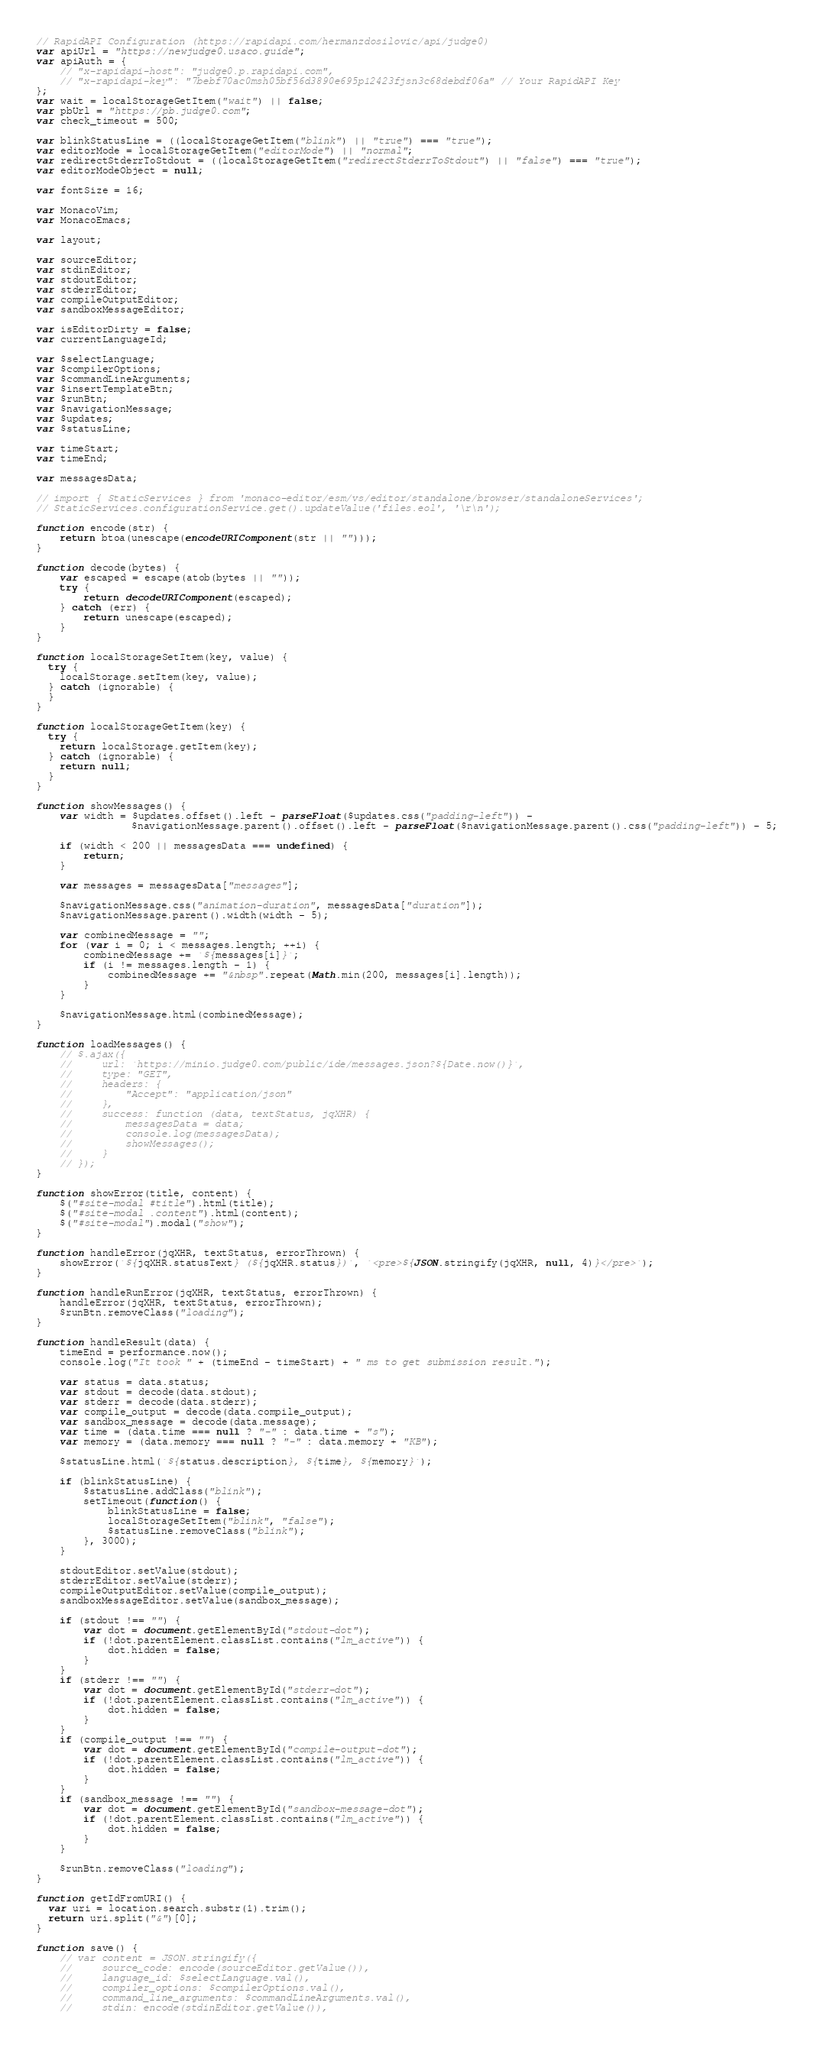Convert code to text. <code><loc_0><loc_0><loc_500><loc_500><_JavaScript_>// RapidAPI Configuration (https://rapidapi.com/hermanzdosilovic/api/judge0)
var apiUrl = "https://newjudge0.usaco.guide";
var apiAuth = {
    // "x-rapidapi-host": "judge0.p.rapidapi.com",
    // "x-rapidapi-key": "7bebf70ac0msh05bf56d3890e695p12423fjsn3c68debdf06a" // Your RapidAPI Key
};
var wait = localStorageGetItem("wait") || false;
var pbUrl = "https://pb.judge0.com";
var check_timeout = 500;

var blinkStatusLine = ((localStorageGetItem("blink") || "true") === "true");
var editorMode = localStorageGetItem("editorMode") || "normal";
var redirectStderrToStdout = ((localStorageGetItem("redirectStderrToStdout") || "false") === "true");
var editorModeObject = null;

var fontSize = 16;

var MonacoVim;
var MonacoEmacs;

var layout;

var sourceEditor;
var stdinEditor;
var stdoutEditor;
var stderrEditor;
var compileOutputEditor;
var sandboxMessageEditor;

var isEditorDirty = false;
var currentLanguageId;

var $selectLanguage;
var $compilerOptions;
var $commandLineArguments;
var $insertTemplateBtn;
var $runBtn;
var $navigationMessage;
var $updates;
var $statusLine;

var timeStart;
var timeEnd;

var messagesData;

// import { StaticServices } from 'monaco-editor/esm/vs/editor/standalone/browser/standaloneServices';
// StaticServices.configurationService.get().updateValue('files.eol', '\r\n');

function encode(str) {
    return btoa(unescape(encodeURIComponent(str || "")));
}

function decode(bytes) {
    var escaped = escape(atob(bytes || ""));
    try {
        return decodeURIComponent(escaped);
    } catch (err) {
        return unescape(escaped);
    }
}

function localStorageSetItem(key, value) {
  try {
    localStorage.setItem(key, value);
  } catch (ignorable) {
  }
}

function localStorageGetItem(key) {
  try {
    return localStorage.getItem(key);
  } catch (ignorable) {
    return null;
  }
}

function showMessages() {
    var width = $updates.offset().left - parseFloat($updates.css("padding-left")) -
                $navigationMessage.parent().offset().left - parseFloat($navigationMessage.parent().css("padding-left")) - 5;

    if (width < 200 || messagesData === undefined) {
        return;
    }

    var messages = messagesData["messages"];

    $navigationMessage.css("animation-duration", messagesData["duration"]);
    $navigationMessage.parent().width(width - 5);

    var combinedMessage = "";
    for (var i = 0; i < messages.length; ++i) {
        combinedMessage += `${messages[i]}`;
        if (i != messages.length - 1) {
            combinedMessage += "&nbsp".repeat(Math.min(200, messages[i].length));
        }
    }

    $navigationMessage.html(combinedMessage);
}

function loadMessages() {
    // $.ajax({
    //     url: `https://minio.judge0.com/public/ide/messages.json?${Date.now()}`,
    //     type: "GET",
    //     headers: {
    //         "Accept": "application/json"
    //     },
    //     success: function (data, textStatus, jqXHR) {
    //         messagesData = data;
    //         console.log(messagesData);
    //         showMessages();
    //     }
    // });
}

function showError(title, content) {
    $("#site-modal #title").html(title);
    $("#site-modal .content").html(content);
    $("#site-modal").modal("show");
}

function handleError(jqXHR, textStatus, errorThrown) {
    showError(`${jqXHR.statusText} (${jqXHR.status})`, `<pre>${JSON.stringify(jqXHR, null, 4)}</pre>`);
}

function handleRunError(jqXHR, textStatus, errorThrown) {
    handleError(jqXHR, textStatus, errorThrown);
    $runBtn.removeClass("loading");
}

function handleResult(data) {
    timeEnd = performance.now();
    console.log("It took " + (timeEnd - timeStart) + " ms to get submission result.");

    var status = data.status;
    var stdout = decode(data.stdout);
    var stderr = decode(data.stderr);
    var compile_output = decode(data.compile_output);
    var sandbox_message = decode(data.message);
    var time = (data.time === null ? "-" : data.time + "s");
    var memory = (data.memory === null ? "-" : data.memory + "KB");

    $statusLine.html(`${status.description}, ${time}, ${memory}`);

    if (blinkStatusLine) {
        $statusLine.addClass("blink");
        setTimeout(function() {
            blinkStatusLine = false;
            localStorageSetItem("blink", "false");
            $statusLine.removeClass("blink");
        }, 3000);
    }

    stdoutEditor.setValue(stdout);
    stderrEditor.setValue(stderr);
    compileOutputEditor.setValue(compile_output);
    sandboxMessageEditor.setValue(sandbox_message);

    if (stdout !== "") {
        var dot = document.getElementById("stdout-dot");
        if (!dot.parentElement.classList.contains("lm_active")) {
            dot.hidden = false;
        }
    }
    if (stderr !== "") {
        var dot = document.getElementById("stderr-dot");
        if (!dot.parentElement.classList.contains("lm_active")) {
            dot.hidden = false;
        }
    }
    if (compile_output !== "") {
        var dot = document.getElementById("compile-output-dot");
        if (!dot.parentElement.classList.contains("lm_active")) {
            dot.hidden = false;
        }
    }
    if (sandbox_message !== "") {
        var dot = document.getElementById("sandbox-message-dot");
        if (!dot.parentElement.classList.contains("lm_active")) {
            dot.hidden = false;
        }
    }

    $runBtn.removeClass("loading");
}

function getIdFromURI() {
  var uri = location.search.substr(1).trim();
  return uri.split("&")[0];
}

function save() {
    // var content = JSON.stringify({
    //     source_code: encode(sourceEditor.getValue()),
    //     language_id: $selectLanguage.val(),
    //     compiler_options: $compilerOptions.val(),
    //     command_line_arguments: $commandLineArguments.val(),
    //     stdin: encode(stdinEditor.getValue()),</code> 